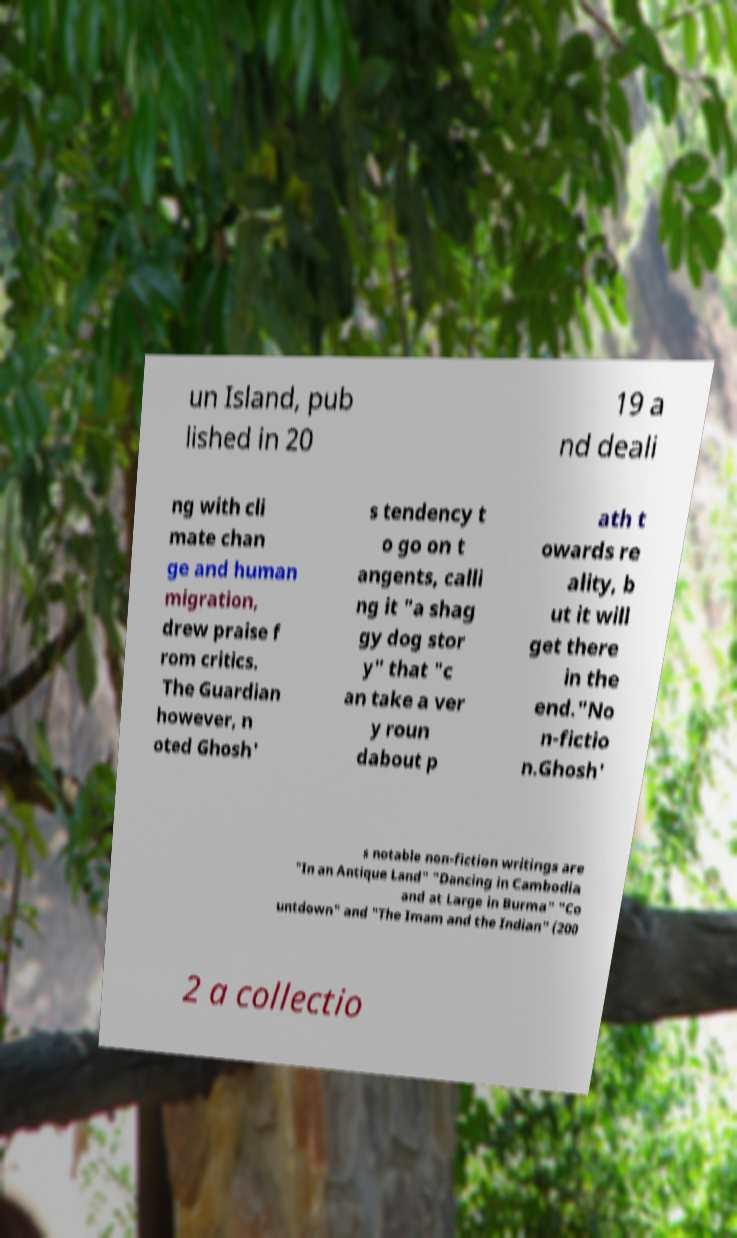For documentation purposes, I need the text within this image transcribed. Could you provide that? un Island, pub lished in 20 19 a nd deali ng with cli mate chan ge and human migration, drew praise f rom critics. The Guardian however, n oted Ghosh' s tendency t o go on t angents, calli ng it "a shag gy dog stor y" that "c an take a ver y roun dabout p ath t owards re ality, b ut it will get there in the end."No n-fictio n.Ghosh' s notable non-fiction writings are "In an Antique Land" "Dancing in Cambodia and at Large in Burma" "Co untdown" and "The Imam and the Indian" (200 2 a collectio 